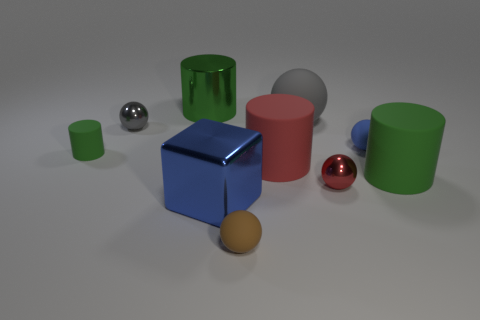Is the large shiny cylinder the same color as the small rubber cylinder?
Ensure brevity in your answer.  Yes. Is there any other thing of the same color as the big metallic cylinder?
Provide a short and direct response. Yes. Does the metal ball that is on the left side of the tiny red metal ball have the same color as the big rubber thing behind the red cylinder?
Keep it short and to the point. Yes. There is a tiny rubber ball in front of the tiny green object; are there any large green cylinders that are on the right side of it?
Keep it short and to the point. Yes. Are there fewer small metal spheres that are right of the large blue cube than objects that are in front of the tiny green cylinder?
Your response must be concise. Yes. Are the blue object that is behind the small green matte object and the gray object left of the red rubber thing made of the same material?
Make the answer very short. No. What number of large objects are either cyan rubber balls or red matte cylinders?
Make the answer very short. 1. There is a red thing that is the same material as the tiny brown ball; what shape is it?
Your answer should be compact. Cylinder. Are there fewer gray shiny balls that are to the right of the large red matte cylinder than small yellow matte cylinders?
Provide a succinct answer. No. Is the shape of the big blue thing the same as the tiny green thing?
Offer a very short reply. No. 